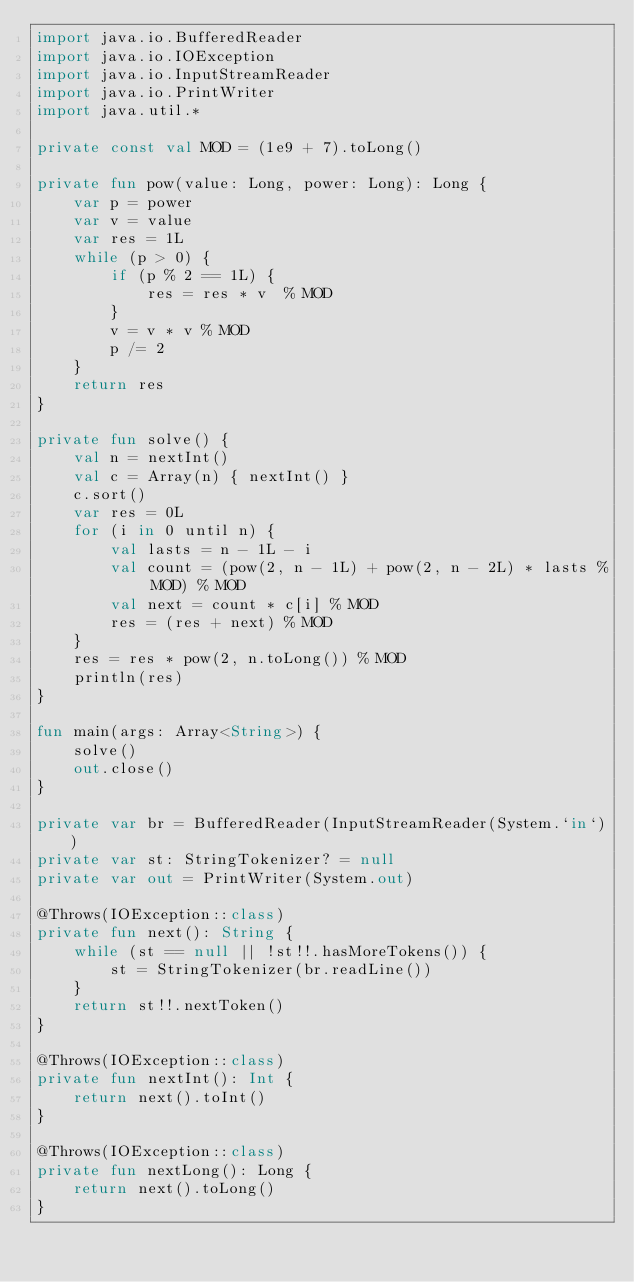Convert code to text. <code><loc_0><loc_0><loc_500><loc_500><_Kotlin_>import java.io.BufferedReader
import java.io.IOException
import java.io.InputStreamReader
import java.io.PrintWriter
import java.util.*

private const val MOD = (1e9 + 7).toLong()

private fun pow(value: Long, power: Long): Long {
    var p = power
    var v = value
    var res = 1L
    while (p > 0) {
        if (p % 2 == 1L) {
            res = res * v  % MOD
        }
        v = v * v % MOD
        p /= 2
    }
    return res
}

private fun solve() {
    val n = nextInt()
    val c = Array(n) { nextInt() }
    c.sort()
    var res = 0L
    for (i in 0 until n) {
        val lasts = n - 1L - i
        val count = (pow(2, n - 1L) + pow(2, n - 2L) * lasts % MOD) % MOD
        val next = count * c[i] % MOD
        res = (res + next) % MOD
    }
    res = res * pow(2, n.toLong()) % MOD
    println(res)
}

fun main(args: Array<String>) {
    solve()
    out.close()
}

private var br = BufferedReader(InputStreamReader(System.`in`))
private var st: StringTokenizer? = null
private var out = PrintWriter(System.out)

@Throws(IOException::class)
private fun next(): String {
    while (st == null || !st!!.hasMoreTokens()) {
        st = StringTokenizer(br.readLine())
    }
    return st!!.nextToken()
}

@Throws(IOException::class)
private fun nextInt(): Int {
    return next().toInt()
}

@Throws(IOException::class)
private fun nextLong(): Long {
    return next().toLong()
}
</code> 